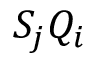Convert formula to latex. <formula><loc_0><loc_0><loc_500><loc_500>S _ { j } Q _ { i }</formula> 